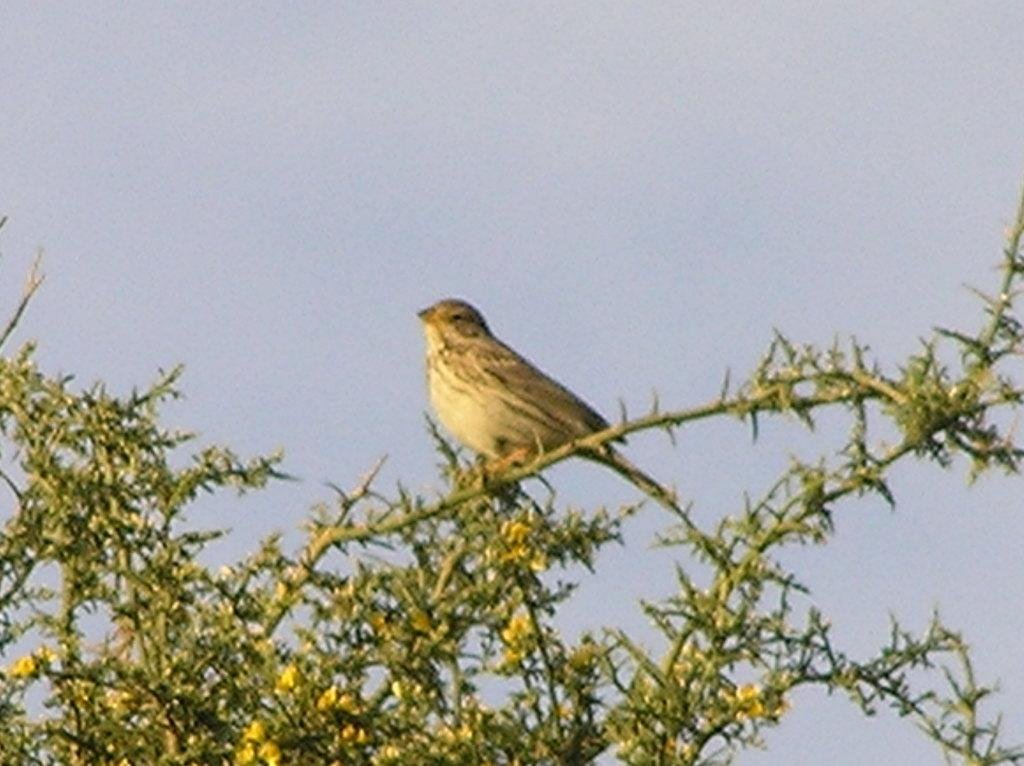What type of vegetation can be seen in the image? There are branches with leaves and flowers in the image. Are there any animals present in the image? Yes, there is a bird on the branches. What can be seen in the background of the image? The sky is visible in the background of the image. What type of cart can be seen in the image? There is no cart present in the image. What sound does the bird make in the image? The image is a still picture, so no sounds can be heard. 